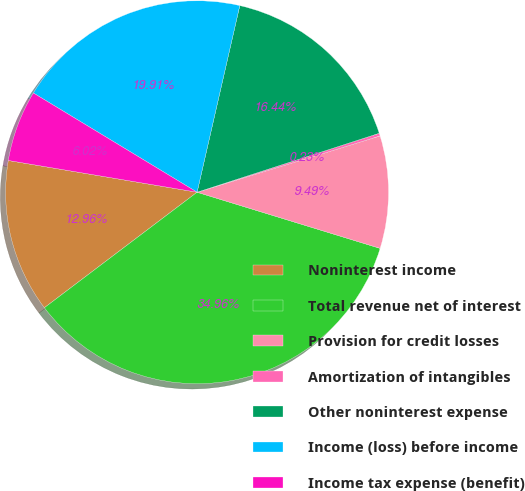Convert chart. <chart><loc_0><loc_0><loc_500><loc_500><pie_chart><fcel>Noninterest income<fcel>Total revenue net of interest<fcel>Provision for credit losses<fcel>Amortization of intangibles<fcel>Other noninterest expense<fcel>Income (loss) before income<fcel>Income tax expense (benefit)<nl><fcel>12.96%<fcel>34.96%<fcel>9.49%<fcel>0.23%<fcel>16.44%<fcel>19.91%<fcel>6.02%<nl></chart> 